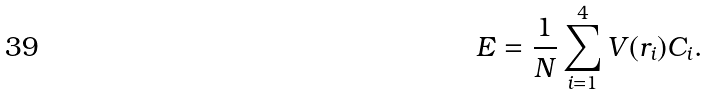<formula> <loc_0><loc_0><loc_500><loc_500>E = \frac { 1 } { N } \sum _ { i = 1 } ^ { 4 } V ( r _ { i } ) C _ { i } .</formula> 